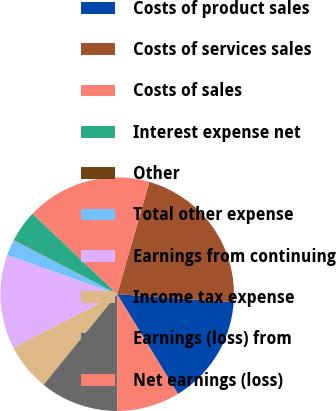<chart> <loc_0><loc_0><loc_500><loc_500><pie_chart><fcel>Costs of product sales<fcel>Costs of services sales<fcel>Costs of sales<fcel>Interest expense net<fcel>Other<fcel>Total other expense<fcel>Earnings from continuing<fcel>Income tax expense<fcel>Earnings (loss) from<fcel>Net earnings (loss)<nl><fcel>15.18%<fcel>21.66%<fcel>17.34%<fcel>4.38%<fcel>0.06%<fcel>2.22%<fcel>13.02%<fcel>6.54%<fcel>10.86%<fcel>8.7%<nl></chart> 